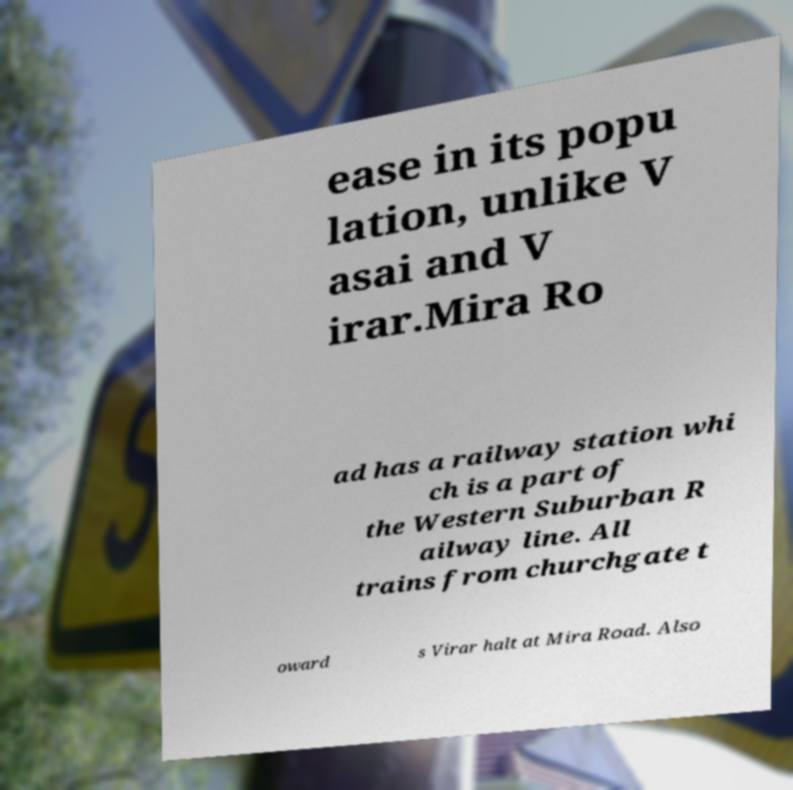Could you extract and type out the text from this image? ease in its popu lation, unlike V asai and V irar.Mira Ro ad has a railway station whi ch is a part of the Western Suburban R ailway line. All trains from churchgate t oward s Virar halt at Mira Road. Also 